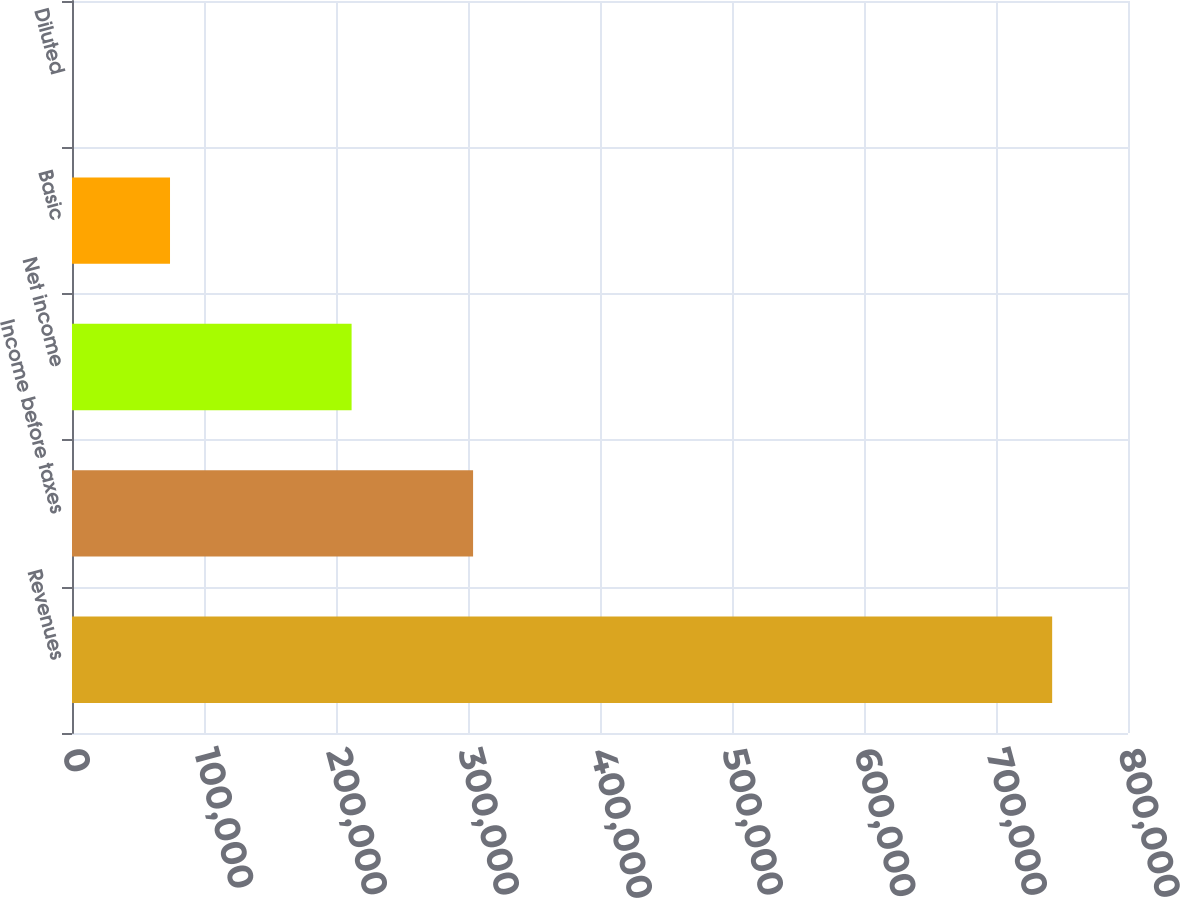<chart> <loc_0><loc_0><loc_500><loc_500><bar_chart><fcel>Revenues<fcel>Income before taxes<fcel>Net income<fcel>Basic<fcel>Diluted<nl><fcel>742545<fcel>303852<fcel>211812<fcel>74255.6<fcel>1.22<nl></chart> 